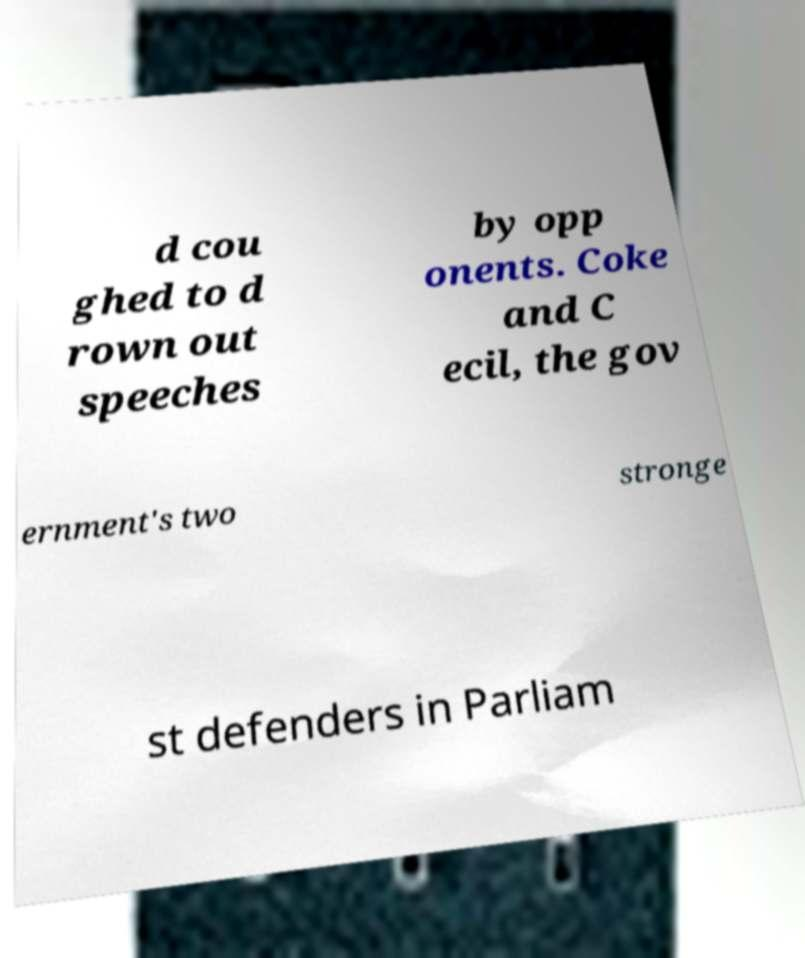Could you extract and type out the text from this image? d cou ghed to d rown out speeches by opp onents. Coke and C ecil, the gov ernment's two stronge st defenders in Parliam 